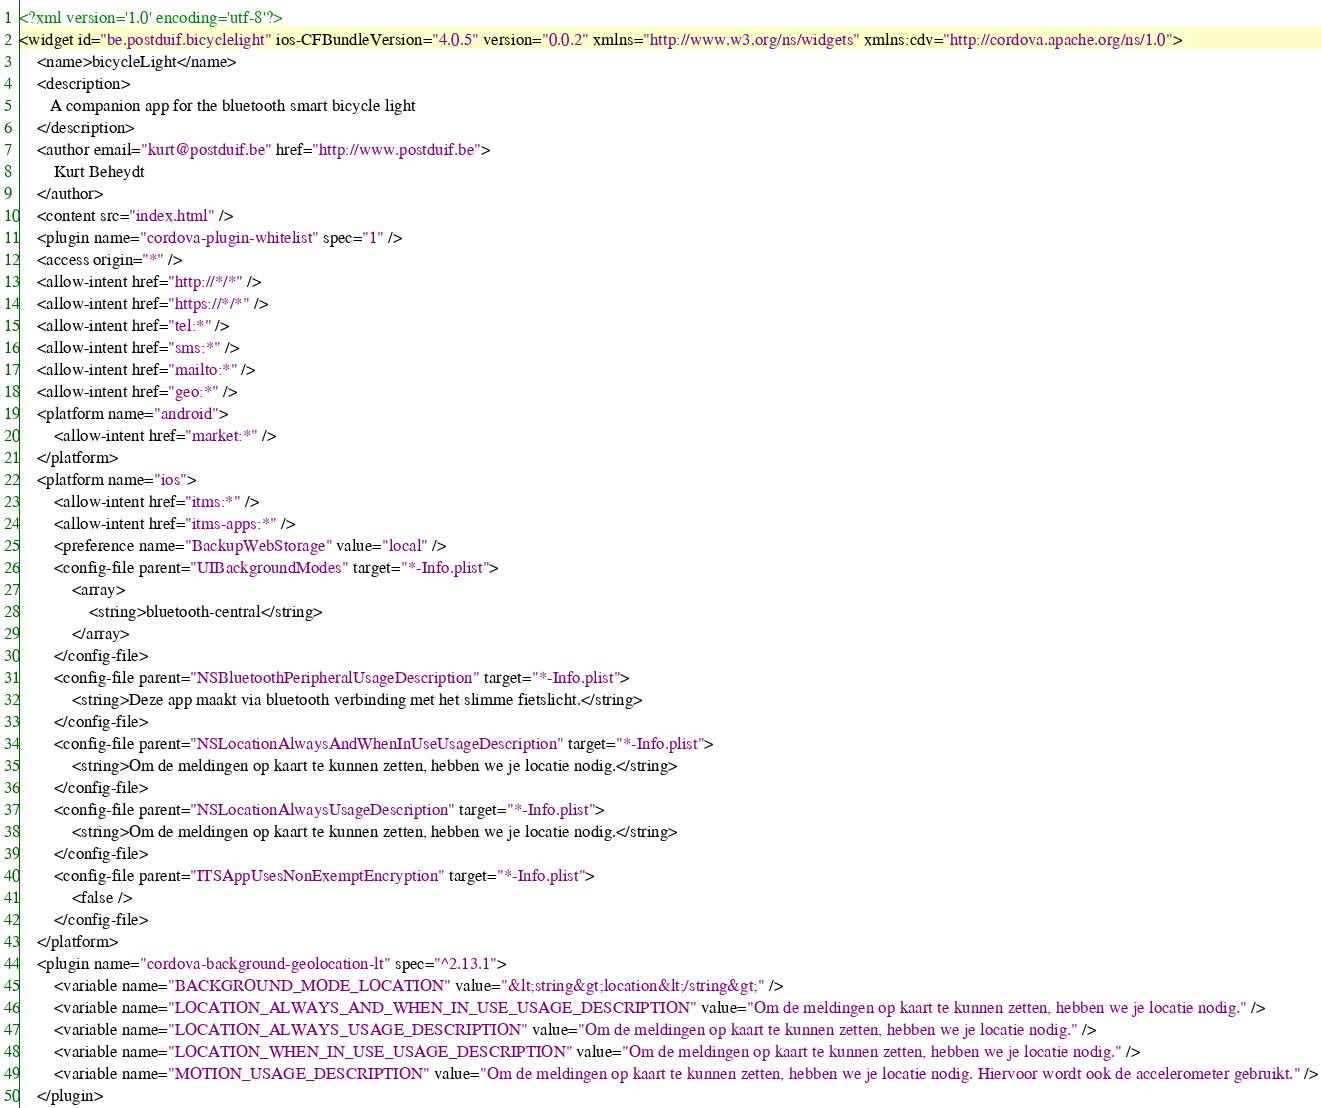Convert code to text. <code><loc_0><loc_0><loc_500><loc_500><_XML_><?xml version='1.0' encoding='utf-8'?>
<widget id="be.postduif.bicyclelight" ios-CFBundleVersion="4.0.5" version="0.0.2" xmlns="http://www.w3.org/ns/widgets" xmlns:cdv="http://cordova.apache.org/ns/1.0">
    <name>bicycleLight</name>
    <description>
       A companion app for the bluetooth smart bicycle light
    </description>
    <author email="kurt@postduif.be" href="http://www.postduif.be">
        Kurt Beheydt
    </author>
    <content src="index.html" />
    <plugin name="cordova-plugin-whitelist" spec="1" />
    <access origin="*" />
    <allow-intent href="http://*/*" />
    <allow-intent href="https://*/*" />
    <allow-intent href="tel:*" />
    <allow-intent href="sms:*" />
    <allow-intent href="mailto:*" />
    <allow-intent href="geo:*" />
    <platform name="android">
        <allow-intent href="market:*" />
    </platform>
    <platform name="ios">
        <allow-intent href="itms:*" />
        <allow-intent href="itms-apps:*" />
        <preference name="BackupWebStorage" value="local" />
        <config-file parent="UIBackgroundModes" target="*-Info.plist">
            <array>
                <string>bluetooth-central</string>
            </array>
        </config-file>
        <config-file parent="NSBluetoothPeripheralUsageDescription" target="*-Info.plist">
            <string>Deze app maakt via bluetooth verbinding met het slimme fietslicht.</string>
        </config-file>
        <config-file parent="NSLocationAlwaysAndWhenInUseUsageDescription" target="*-Info.plist">
            <string>Om de meldingen op kaart te kunnen zetten, hebben we je locatie nodig.</string>
        </config-file>
        <config-file parent="NSLocationAlwaysUsageDescription" target="*-Info.plist">
            <string>Om de meldingen op kaart te kunnen zetten, hebben we je locatie nodig.</string>
        </config-file>
        <config-file parent="ITSAppUsesNonExemptEncryption" target="*-Info.plist">
            <false />
        </config-file>
    </platform>
    <plugin name="cordova-background-geolocation-lt" spec="^2.13.1">
        <variable name="BACKGROUND_MODE_LOCATION" value="&lt;string&gt;location&lt;/string&gt;" />
        <variable name="LOCATION_ALWAYS_AND_WHEN_IN_USE_USAGE_DESCRIPTION" value="Om de meldingen op kaart te kunnen zetten, hebben we je locatie nodig." />
        <variable name="LOCATION_ALWAYS_USAGE_DESCRIPTION" value="Om de meldingen op kaart te kunnen zetten, hebben we je locatie nodig." />
        <variable name="LOCATION_WHEN_IN_USE_USAGE_DESCRIPTION" value="Om de meldingen op kaart te kunnen zetten, hebben we je locatie nodig." />
        <variable name="MOTION_USAGE_DESCRIPTION" value="Om de meldingen op kaart te kunnen zetten, hebben we je locatie nodig. Hiervoor wordt ook de accelerometer gebruikt." />
    </plugin></code> 